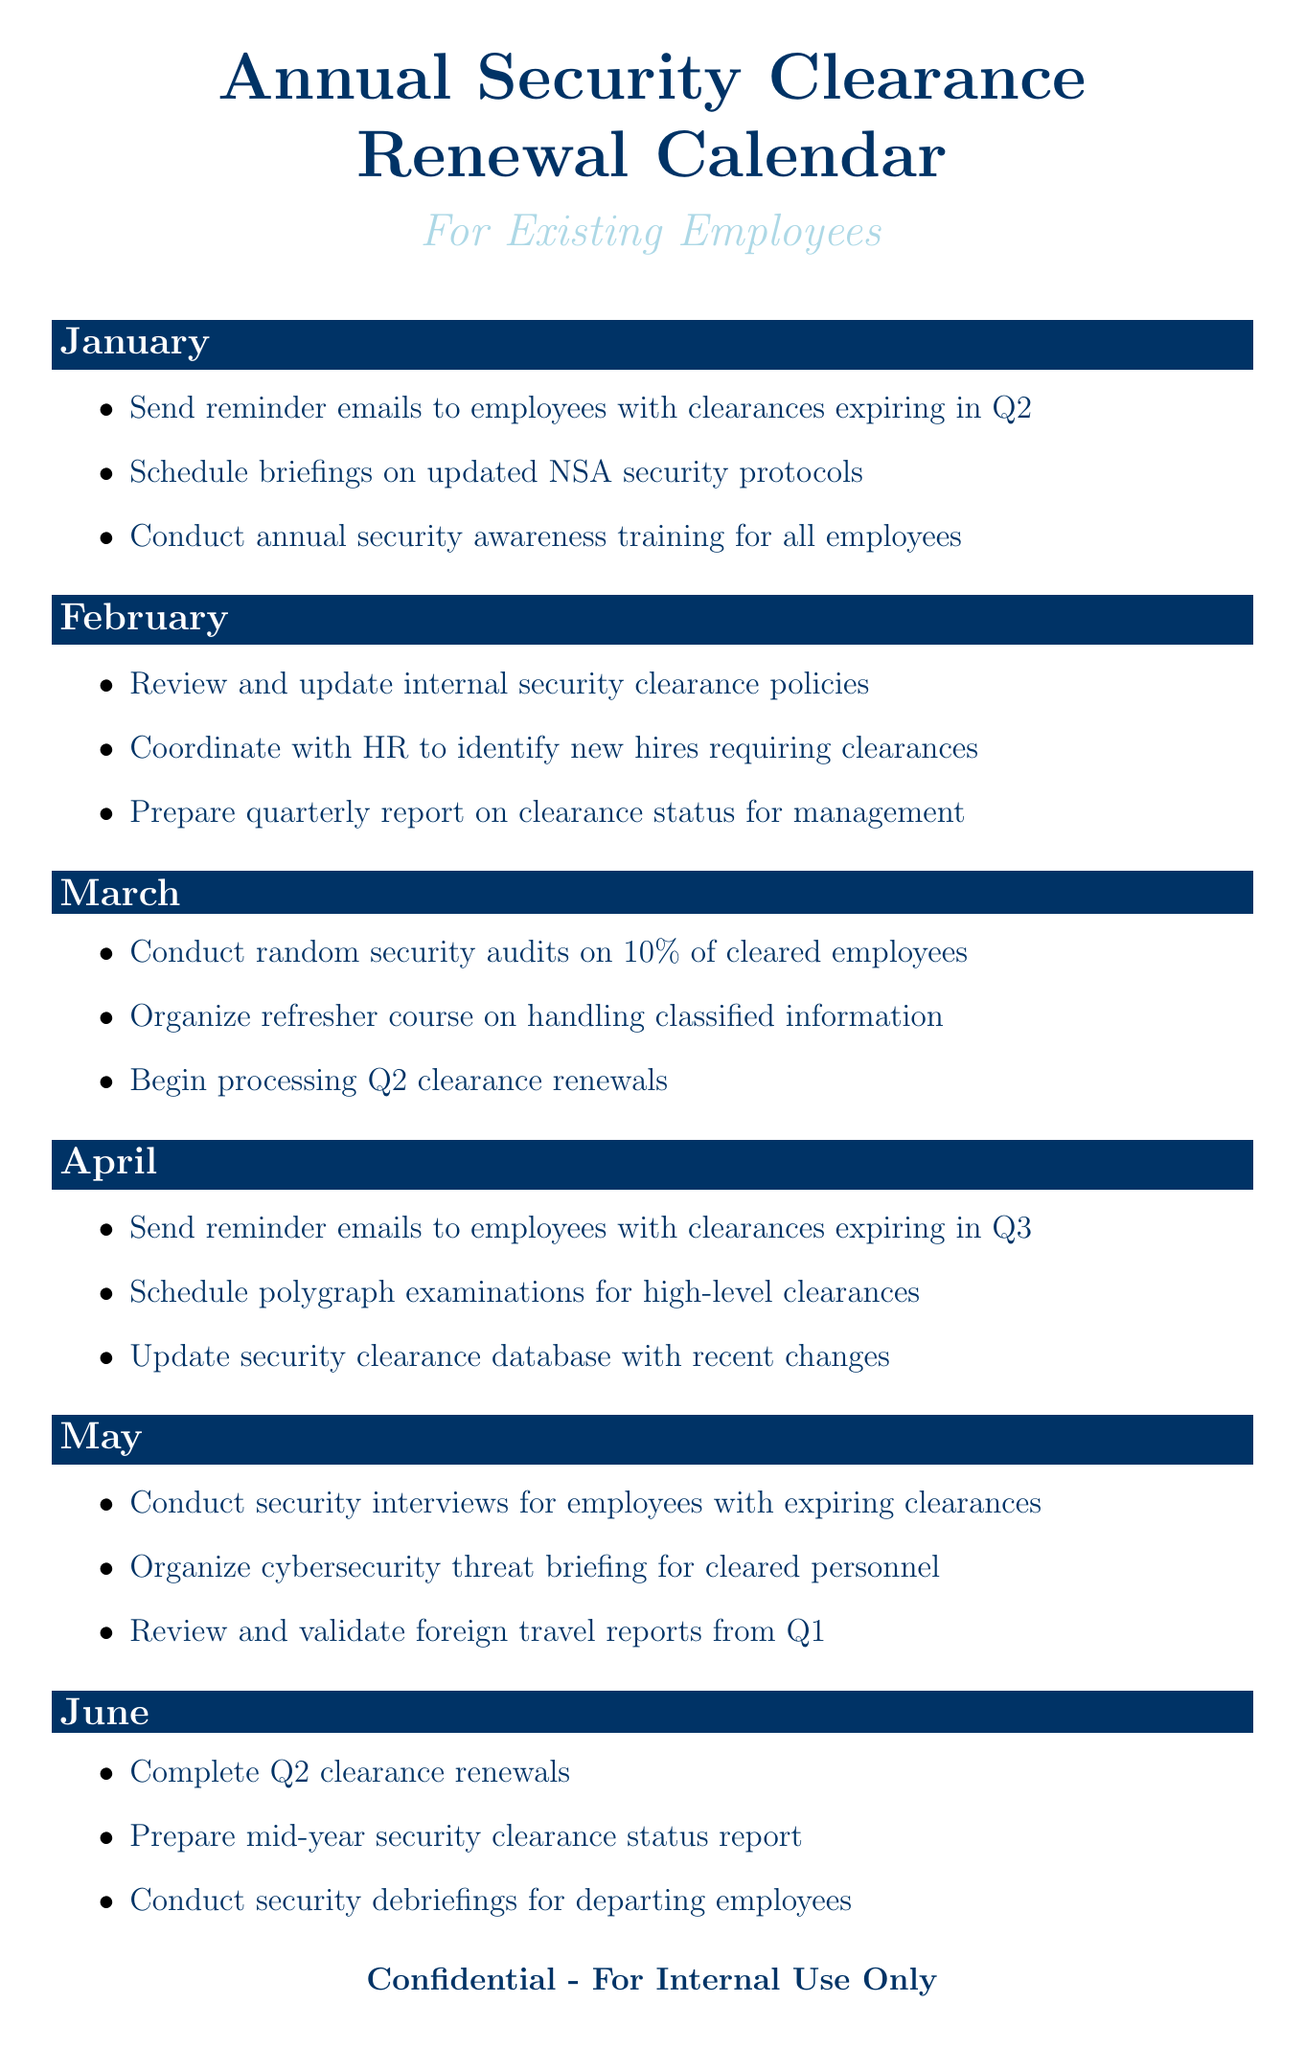What tasks are scheduled for January? The tasks listed for January include sending reminder emails, scheduling briefings on updated NSA security protocols, and conducting annual security awareness training.
Answer: Send reminder emails to employees with clearances expiring in Q2, Schedule briefings on updated NSA security protocols, Conduct annual security awareness training for all employees How many clearance levels are mentioned? The document lists four clearance levels: Confidential, Secret, Top Secret, and Top Secret/SCI.
Answer: Four What is the task for March? The tasks listed for March include conducting random security audits, organizing a refresher course, and beginning processing for Q2 clearance renewals.
Answer: Conduct random security audits on 10% of cleared employees, Organize refresher course on handling classified information, Begin processing Q2 clearance renewals Which month requires a review of foreign travel reports from Q1? The task to review and validate foreign travel reports is scheduled for May.
Answer: May What is one of the additional tasks mentioned? One of the additional tasks is to coordinate with the FBI for periodic background checks.
Answer: Coordinate with FBI for periodic background checks 